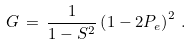Convert formula to latex. <formula><loc_0><loc_0><loc_500><loc_500>G \, = \, \frac { 1 } { 1 - S ^ { 2 } } \left ( 1 - 2 P _ { e } \right ) ^ { 2 } \, .</formula> 